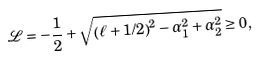<formula> <loc_0><loc_0><loc_500><loc_500>\mathcal { L = - } \frac { 1 } { 2 } + \sqrt { \left ( \ell + 1 / 2 \right ) ^ { 2 } - \alpha _ { 1 } ^ { 2 } + \alpha _ { 2 } ^ { 2 } } \geq 0 ,</formula> 